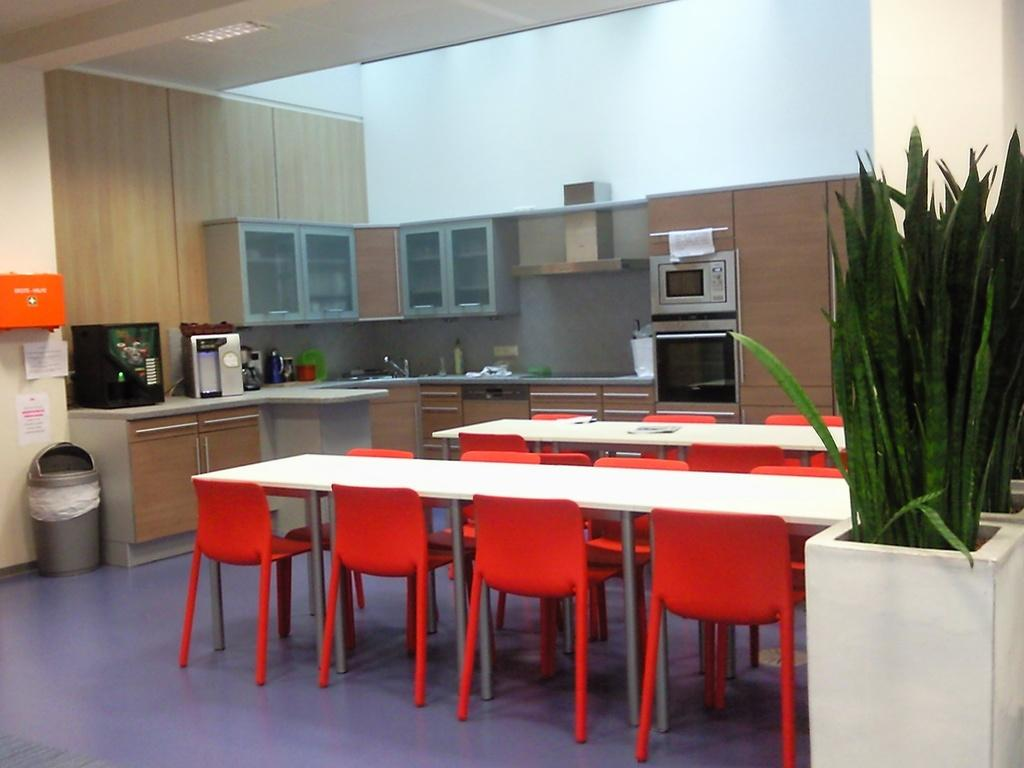What type of furniture is present in the image? There are tables and chairs in the image. What other items can be seen in the image? There are plants, cupboards, a microwave oven, and a tap in the image. Can you describe the plants in the image? The plants are unspecified, but they are present in the image. What type of trousers are being worn by the plants in the image? There are no people or trousers present in the image, as it features plants, furniture, and appliances. 